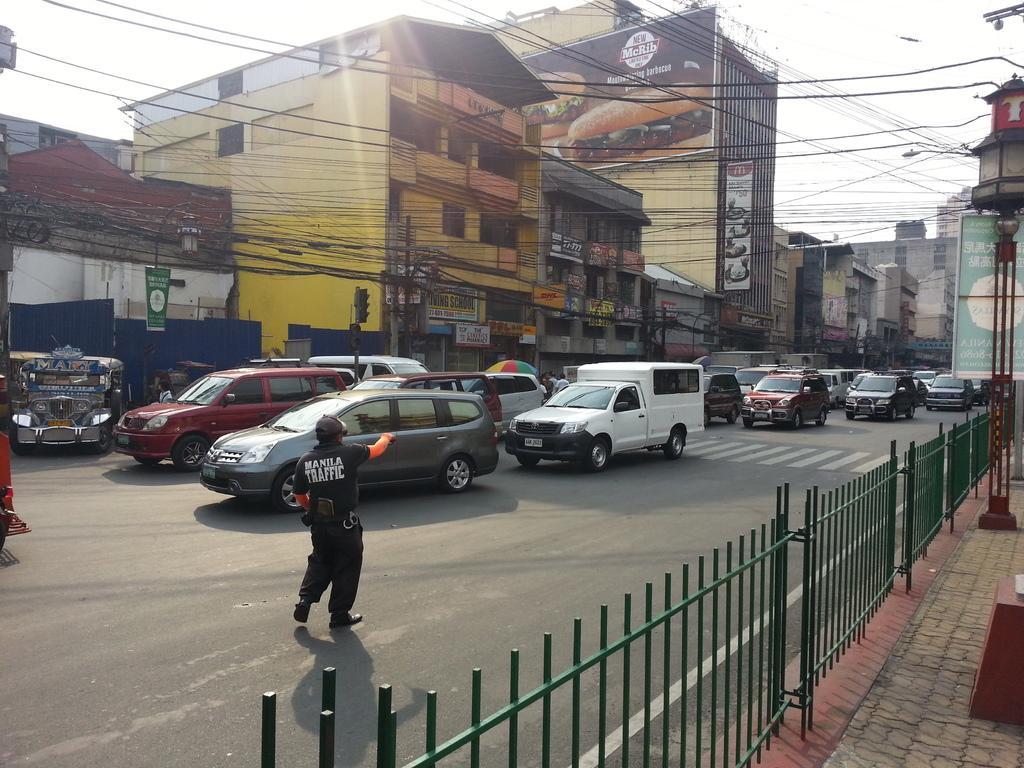Please provide a concise description of this image. In this image we can see a few buildings, there are some vehicles, lights, poles, boards, people, wires and fence, in the background, we can see the sky. 